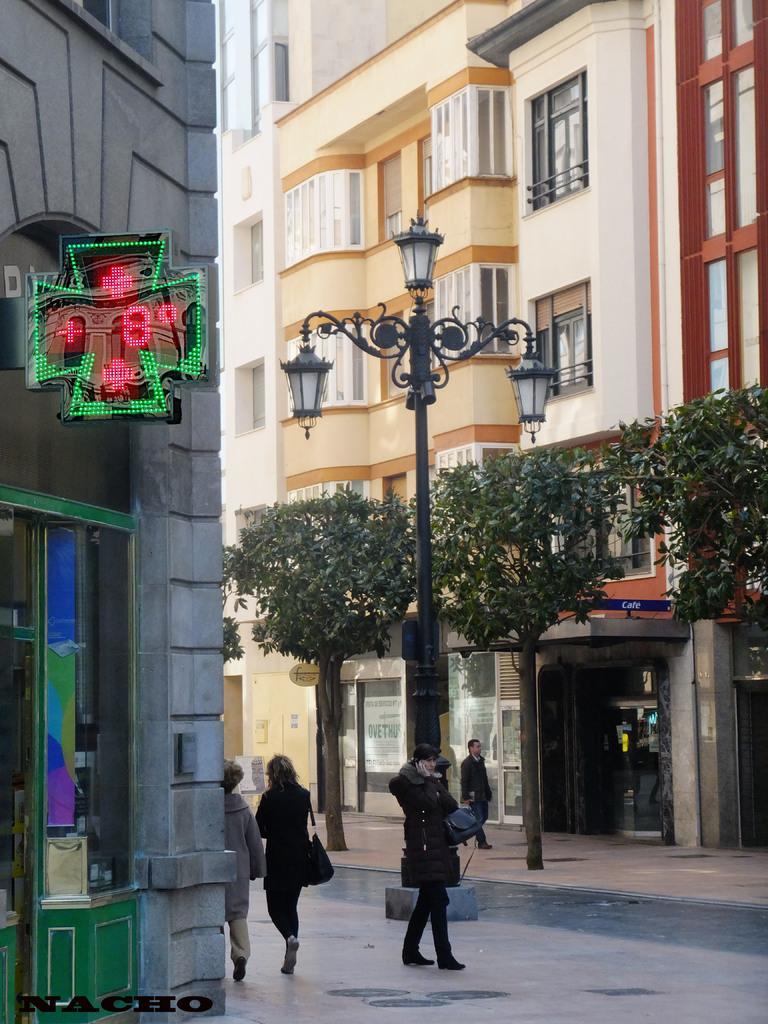How would you summarize this image in a sentence or two? In this image I see few buildings and I see the shops and I see a board over here which is in green and red in color and I see that it is digital and I see few people on the path and I see a street light over here and I see the trees. 